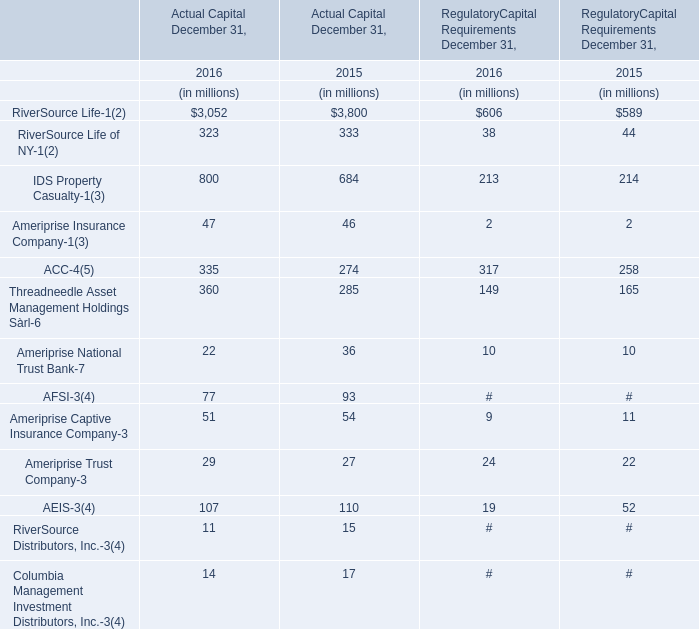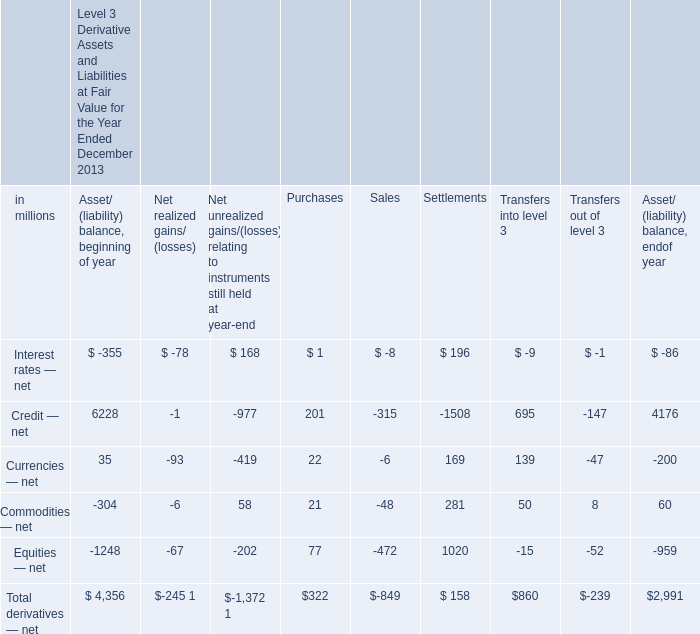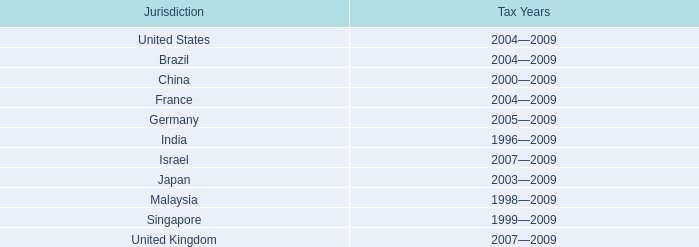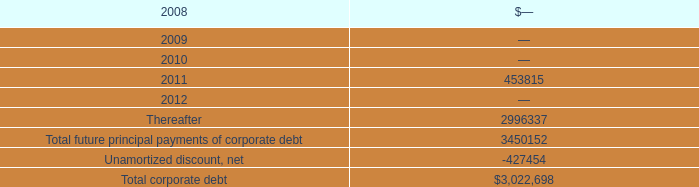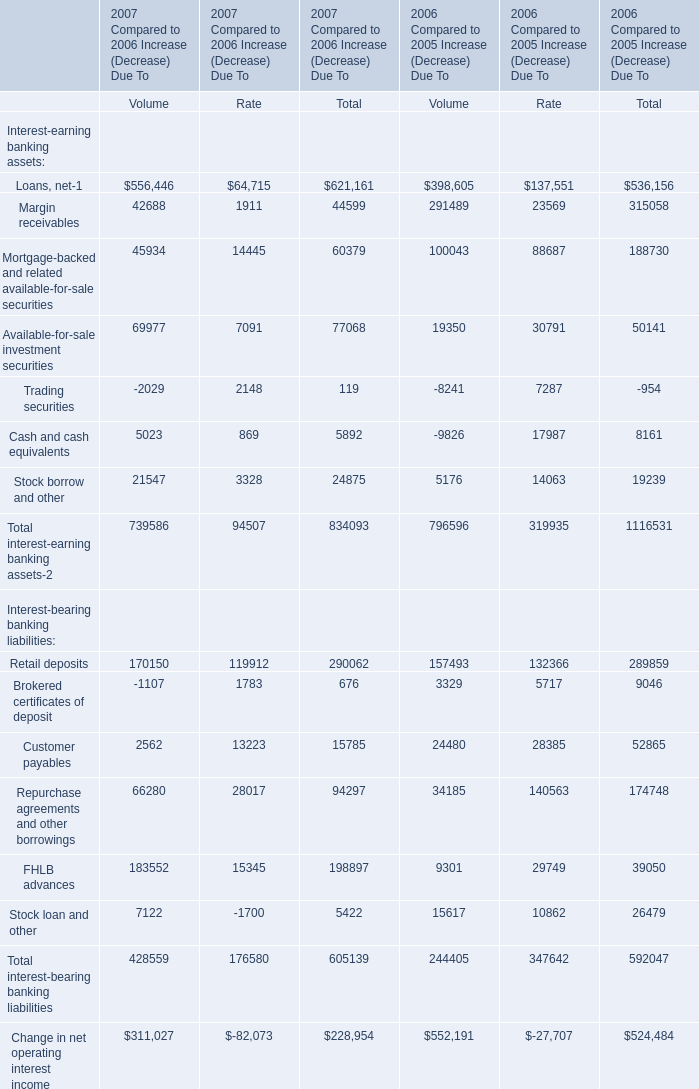Which year is Actual Capital of RiverSource Life the least? (in millions) 
Answer: 3052. 